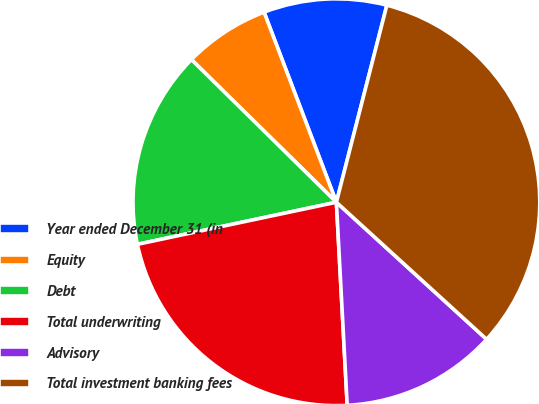<chart> <loc_0><loc_0><loc_500><loc_500><pie_chart><fcel>Year ended December 31 (in<fcel>Equity<fcel>Debt<fcel>Total underwriting<fcel>Advisory<fcel>Total investment banking fees<nl><fcel>9.78%<fcel>6.84%<fcel>15.69%<fcel>22.53%<fcel>12.38%<fcel>32.78%<nl></chart> 